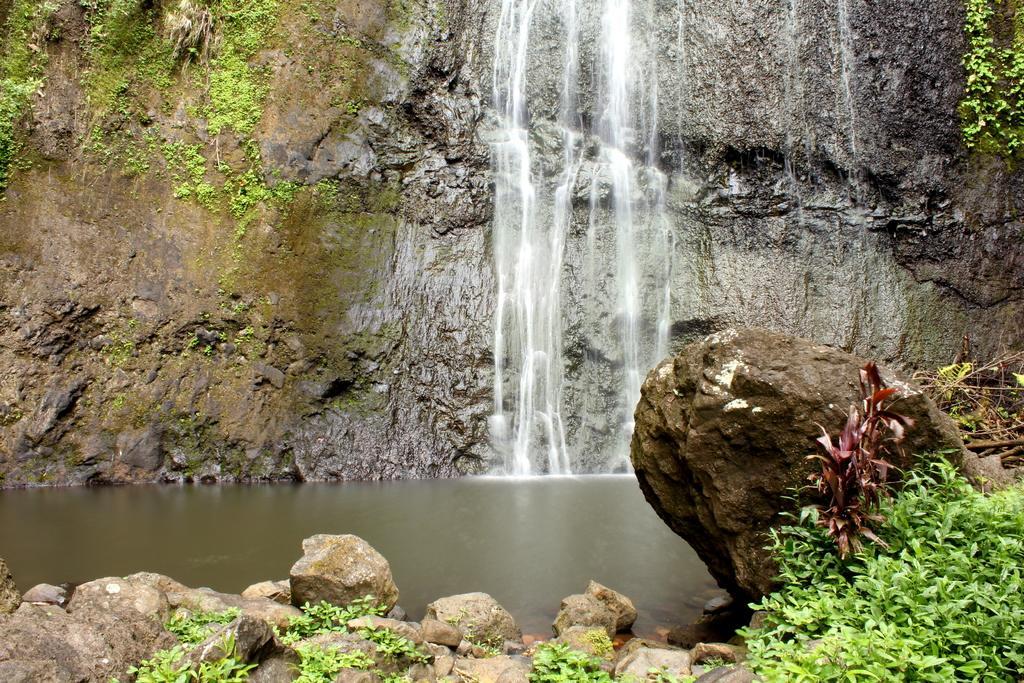Could you give a brief overview of what you see in this image? In the picture I can see plants, rocks, waterfall and the hills in the background. 